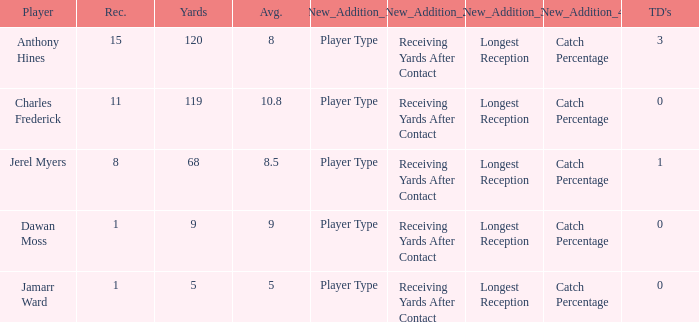What is the highest number of TDs when the Avg is larger than 8.5 and the Rec is less than 1? None. 